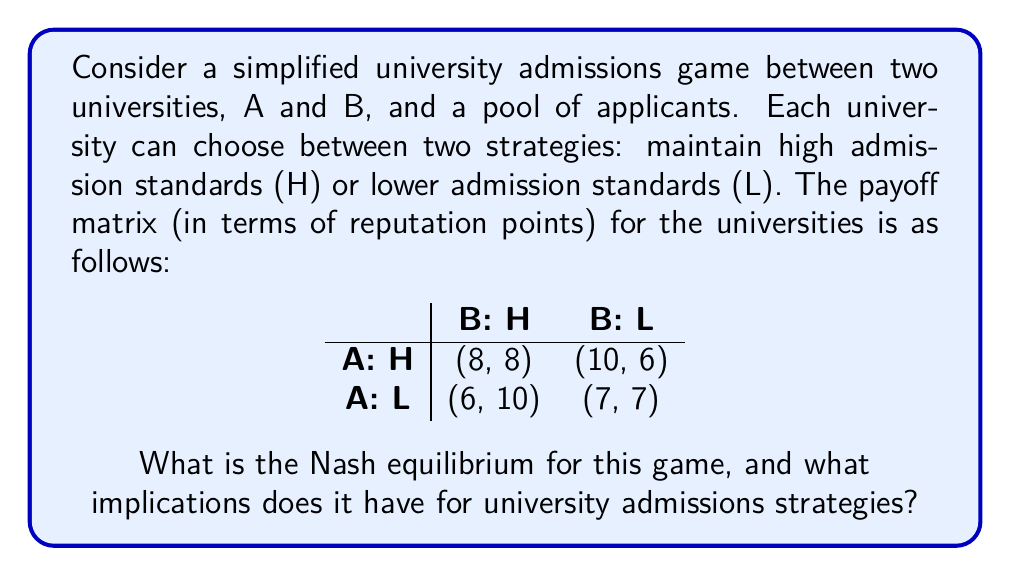Teach me how to tackle this problem. To find the Nash equilibrium, we need to analyze each university's best response to the other's strategy:

1. If University B chooses H:
   - University A's payoff for H: 8
   - University A's payoff for L: 6
   University A's best response is H

2. If University B chooses L:
   - University A's payoff for H: 10
   - University A's payoff for L: 7
   University A's best response is H

3. If University A chooses H:
   - University B's payoff for H: 8
   - University B's payoff for L: 6
   University B's best response is H

4. If University A chooses L:
   - University B's payoff for H: 10
   - University B's payoff for L: 7
   University B's best response is H

The Nash equilibrium is the strategy profile where each player is playing their best response to the other player's strategy. In this case, the Nash equilibrium is (H, H), where both universities maintain high admission standards.

Implications for university admissions strategies:

1. Reputation preservation: The Nash equilibrium suggests that maintaining high standards is the most beneficial strategy for both universities in terms of reputation.

2. Competitive pressure: Even though lowering standards might temporarily increase enrollment, the equilibrium shows that it's not a sustainable long-term strategy.

3. Quality focus: The game encourages universities to focus on the quality of education and student outcomes rather than just increasing enrollment numbers.

4. Applicant behavior: This equilibrium might influence applicants to strive for higher academic achievements to meet the maintained high standards.

5. Industry trends: If this game reflects real-world dynamics, it could explain why prestigious universities tend to maintain or increase their admission standards over time.
Answer: The Nash equilibrium for this game is (H, H), where both universities maintain high admission standards. This equilibrium implies that universities are incentivized to focus on maintaining high academic standards and reputation rather than competing by lowering admission requirements. 